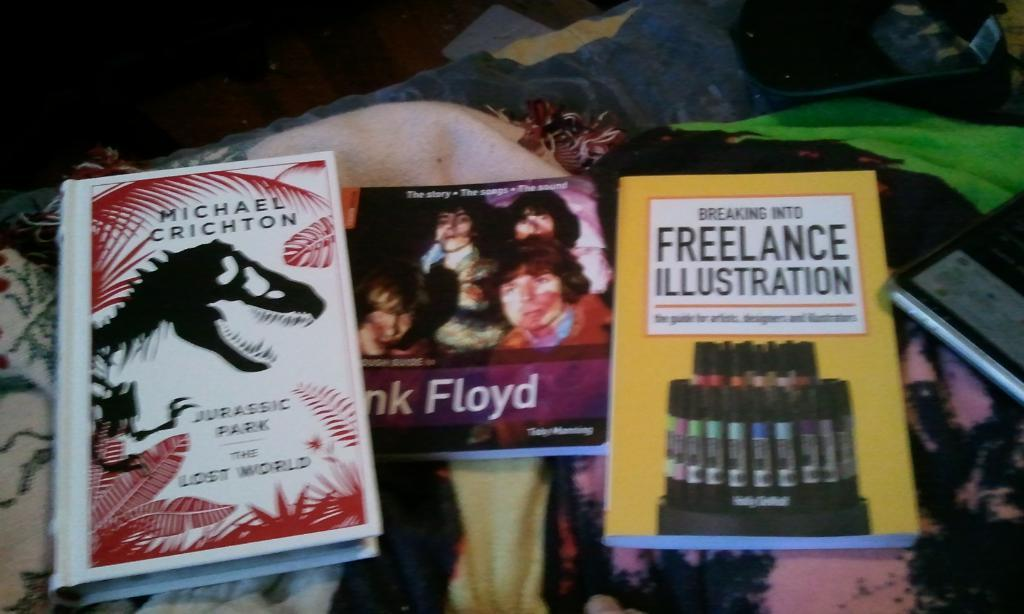<image>
Describe the image concisely. Three books on a table that are Jurassic Park, Pink Floyd and Freelance Illustration. 